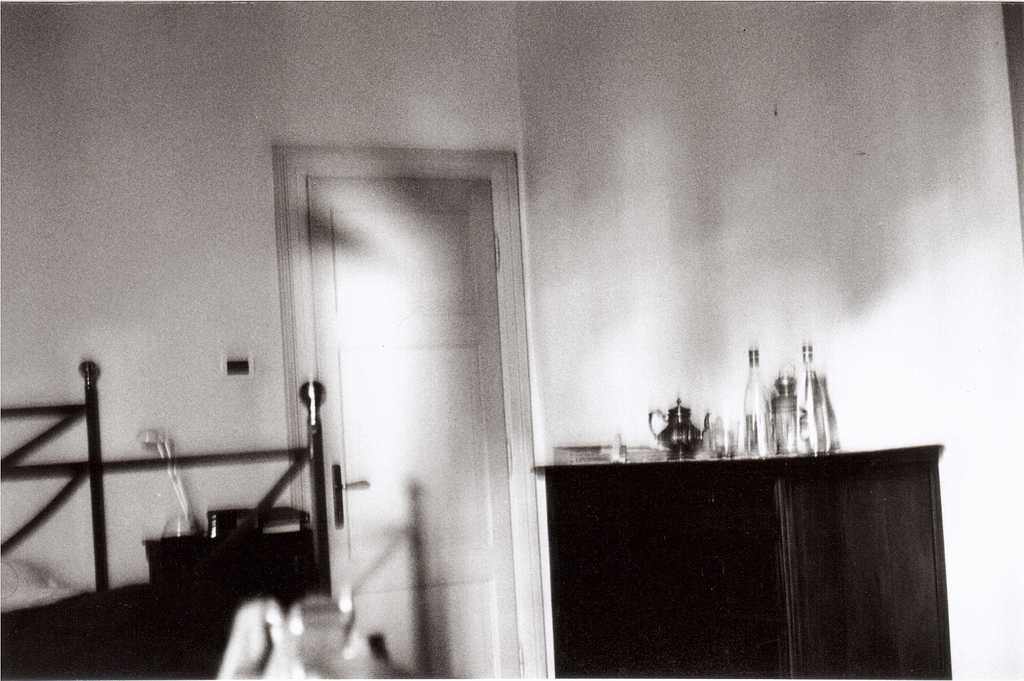What type of location is depicted in the image? The image shows an inside view of a room. What objects can be seen on the table in the room? There are bottles on a table in the room. Are there any other objects on the table besides the bottles? Yes, there are other unspecified things on the table. What type of cheese is being stitched together on the table in the image? There is no cheese or stitching activity present in the image; it only shows bottles and unspecified objects on a table in a room. 